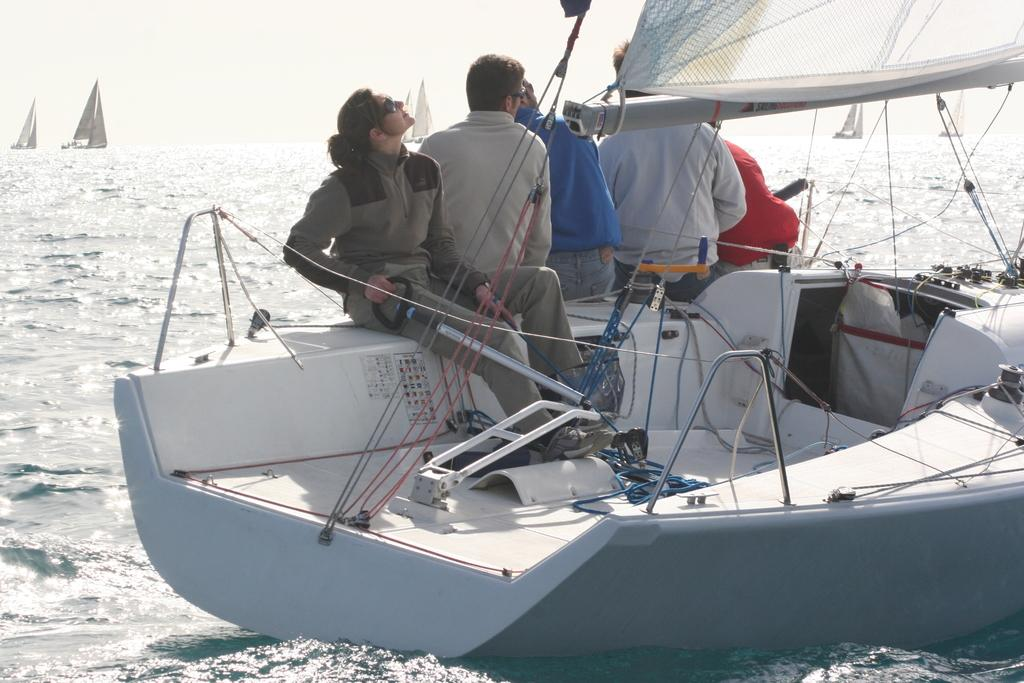What are the people in the image doing? There are persons sitting in a boat in the image. What is on the left side of the image? There is water on the left side of the image. What can be seen in the background of the image? There are boats visible in the background. What is visible at the top of the image? The sky is visible at the top of the image. What memory does the boat evoke for the persons sitting in it? There is no information about the personal memories or emotions of the persons in the image, so it cannot be determined from the image alone. 